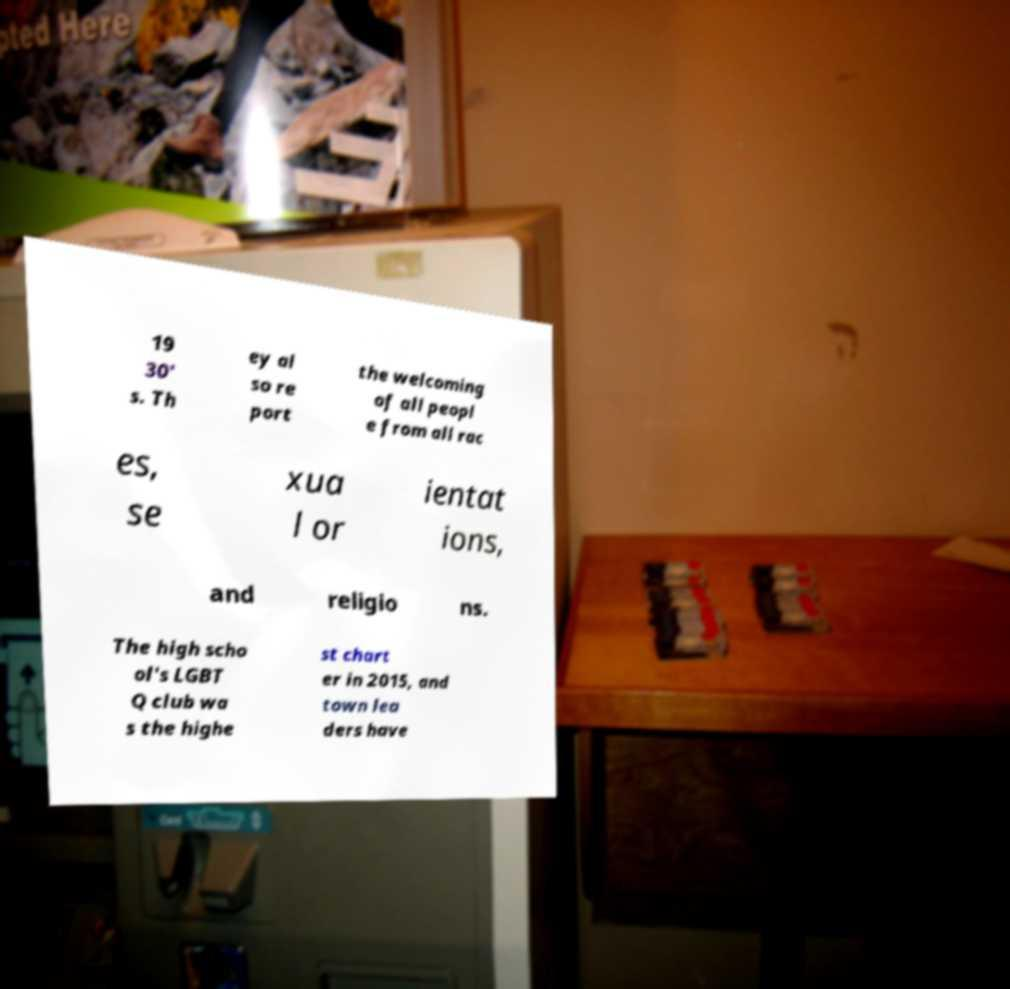I need the written content from this picture converted into text. Can you do that? 19 30' s. Th ey al so re port the welcoming of all peopl e from all rac es, se xua l or ientat ions, and religio ns. The high scho ol's LGBT Q club wa s the highe st chart er in 2015, and town lea ders have 